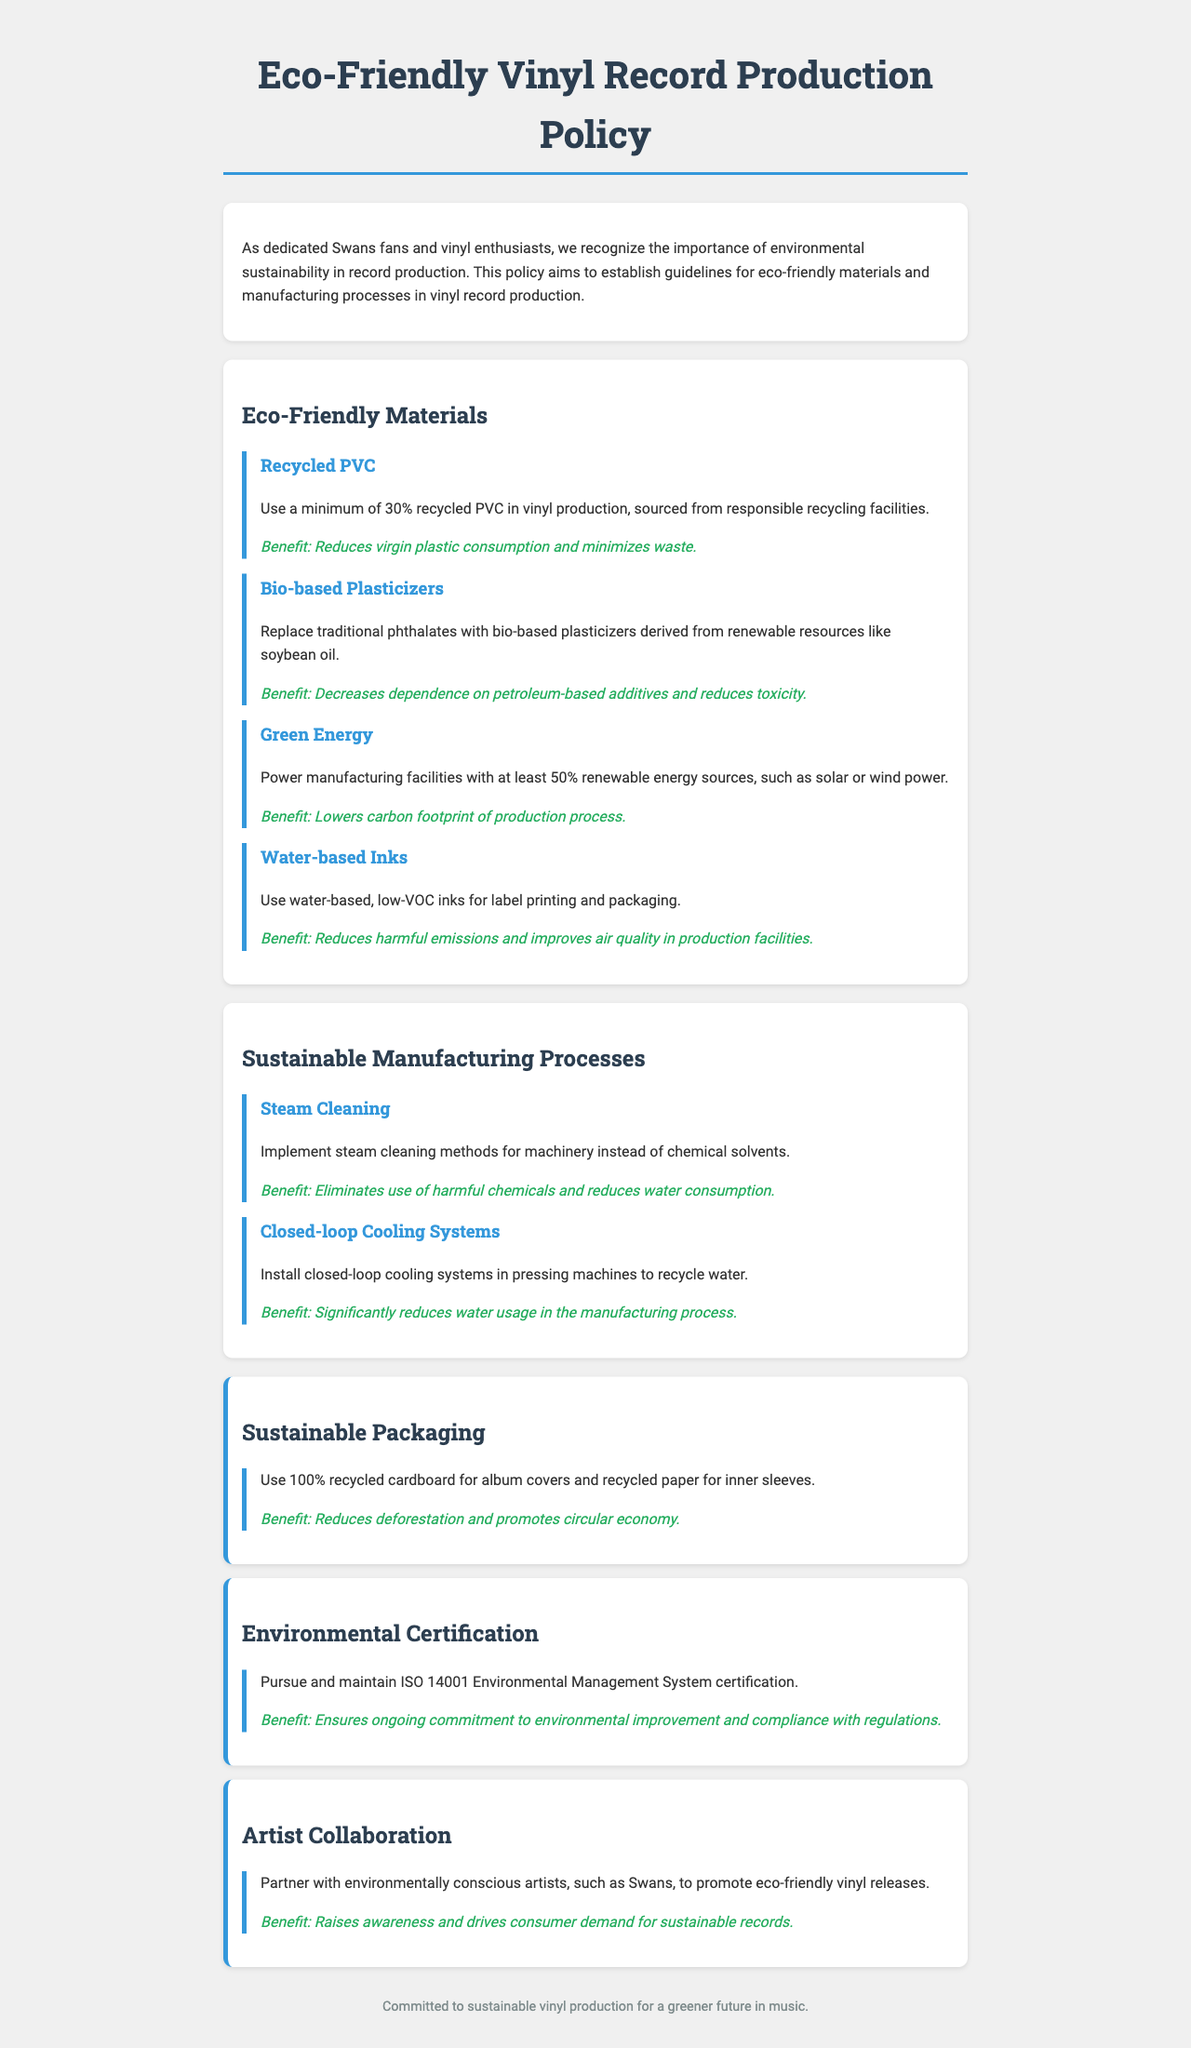What percentage of recycled PVC must be used in vinyl production? The document states that a minimum of 30% recycled PVC must be used in vinyl production.
Answer: 30% What type of plasticizers should be used instead of traditional phthalates? The policy recommends using bio-based plasticizers derived from renewable resources like soybean oil.
Answer: Bio-based plasticizers What energy sources should power manufacturing facilities? The document specifies that at least 50% of renewable energy sources, such as solar or wind power, should be used to power manufacturing facilities.
Answer: 50% What certification should be pursued and maintained? The document mentions pursuing and maintaining ISO 14001 Environmental Management System certification.
Answer: ISO 14001 What should be used for label printing and packaging? The document states that water-based, low-VOC inks should be used for label printing and packaging.
Answer: Water-based inks What is a benefit of using 100% recycled cardboard for album covers? The document states that using 100% recycled cardboard reduces deforestation and promotes a circular economy.
Answer: Reduces deforestation How do closed-loop cooling systems benefit manufacturing? The document mentions that closed-loop cooling systems significantly reduce water usage in the manufacturing process.
Answer: Reduce water usage Who should vinyl producers partner with to promote eco-friendly vinyl releases? The document highlights partnering with environmentally conscious artists, such as Swans.
Answer: Environmentally conscious artists What method is recommended for cleaning machinery? The policy suggests implementing steam cleaning methods instead of chemical solvents for cleaning machinery.
Answer: Steam cleaning methods 